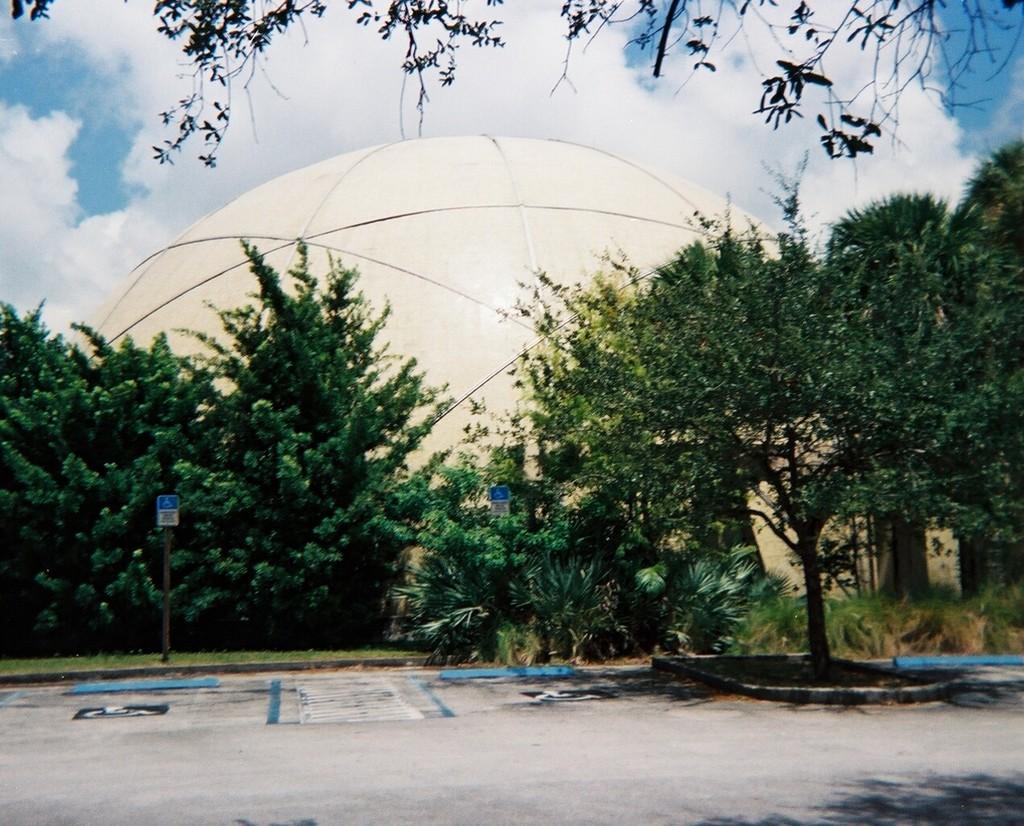Please provide a concise description of this image. In the foreground of this picture, there is a path to walk, few trees, poles and a dome. On the top, there is sky and the cloud. 